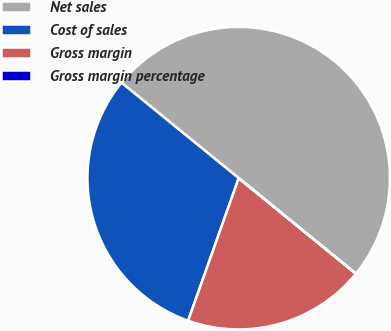Convert chart. <chart><loc_0><loc_0><loc_500><loc_500><pie_chart><fcel>Net sales<fcel>Cost of sales<fcel>Gross margin<fcel>Gross margin percentage<nl><fcel>50.0%<fcel>30.46%<fcel>19.54%<fcel>0.01%<nl></chart> 